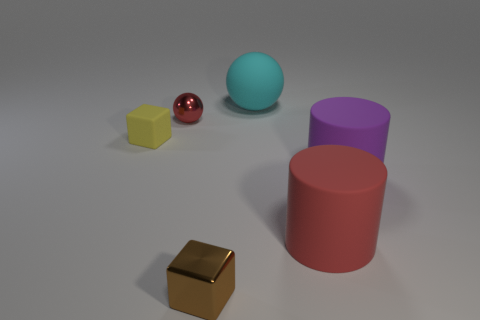Add 4 tiny blue blocks. How many objects exist? 10 Subtract all cylinders. How many objects are left? 4 Add 4 small brown metal things. How many small brown metal things are left? 5 Add 1 brown cubes. How many brown cubes exist? 2 Subtract 0 brown spheres. How many objects are left? 6 Subtract all large brown metallic cylinders. Subtract all cubes. How many objects are left? 4 